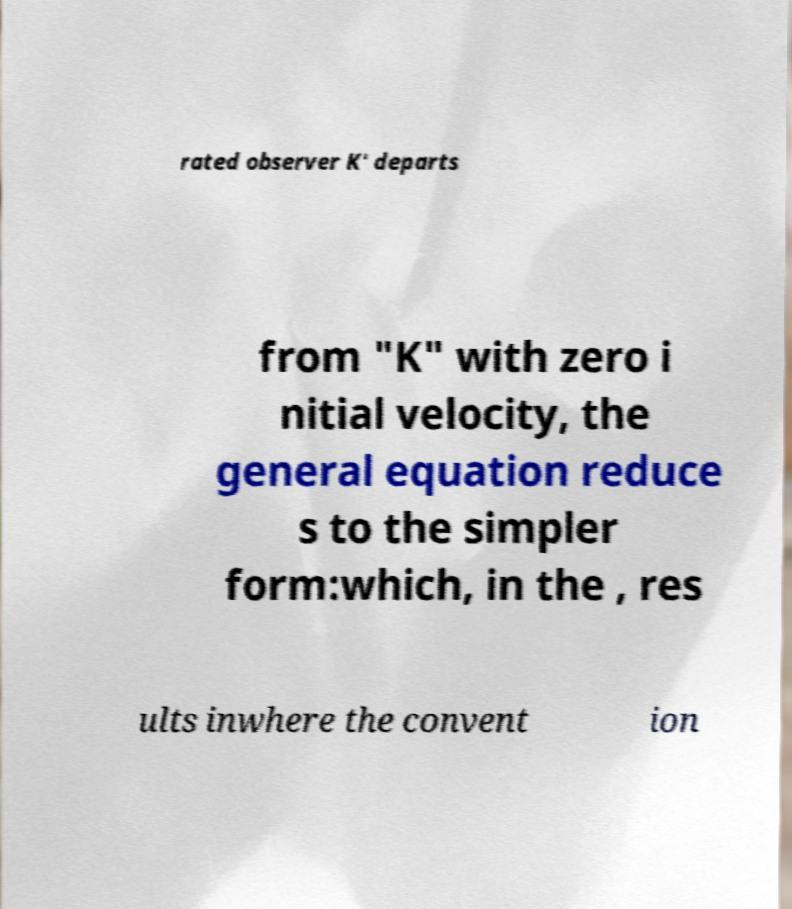Could you extract and type out the text from this image? rated observer K' departs from "K" with zero i nitial velocity, the general equation reduce s to the simpler form:which, in the , res ults inwhere the convent ion 